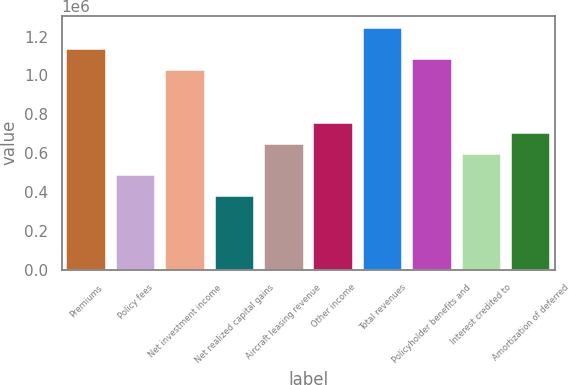Convert chart. <chart><loc_0><loc_0><loc_500><loc_500><bar_chart><fcel>Premiums<fcel>Policy fees<fcel>Net investment income<fcel>Net realized capital gains<fcel>Aircraft leasing revenue<fcel>Other income<fcel>Total revenues<fcel>Policyholder benefits and<fcel>Interest credited to<fcel>Amortization of deferred<nl><fcel>1.13674e+06<fcel>487201<fcel>1.02848e+06<fcel>378945<fcel>649585<fcel>757841<fcel>1.24499e+06<fcel>1.08261e+06<fcel>595457<fcel>703713<nl></chart> 